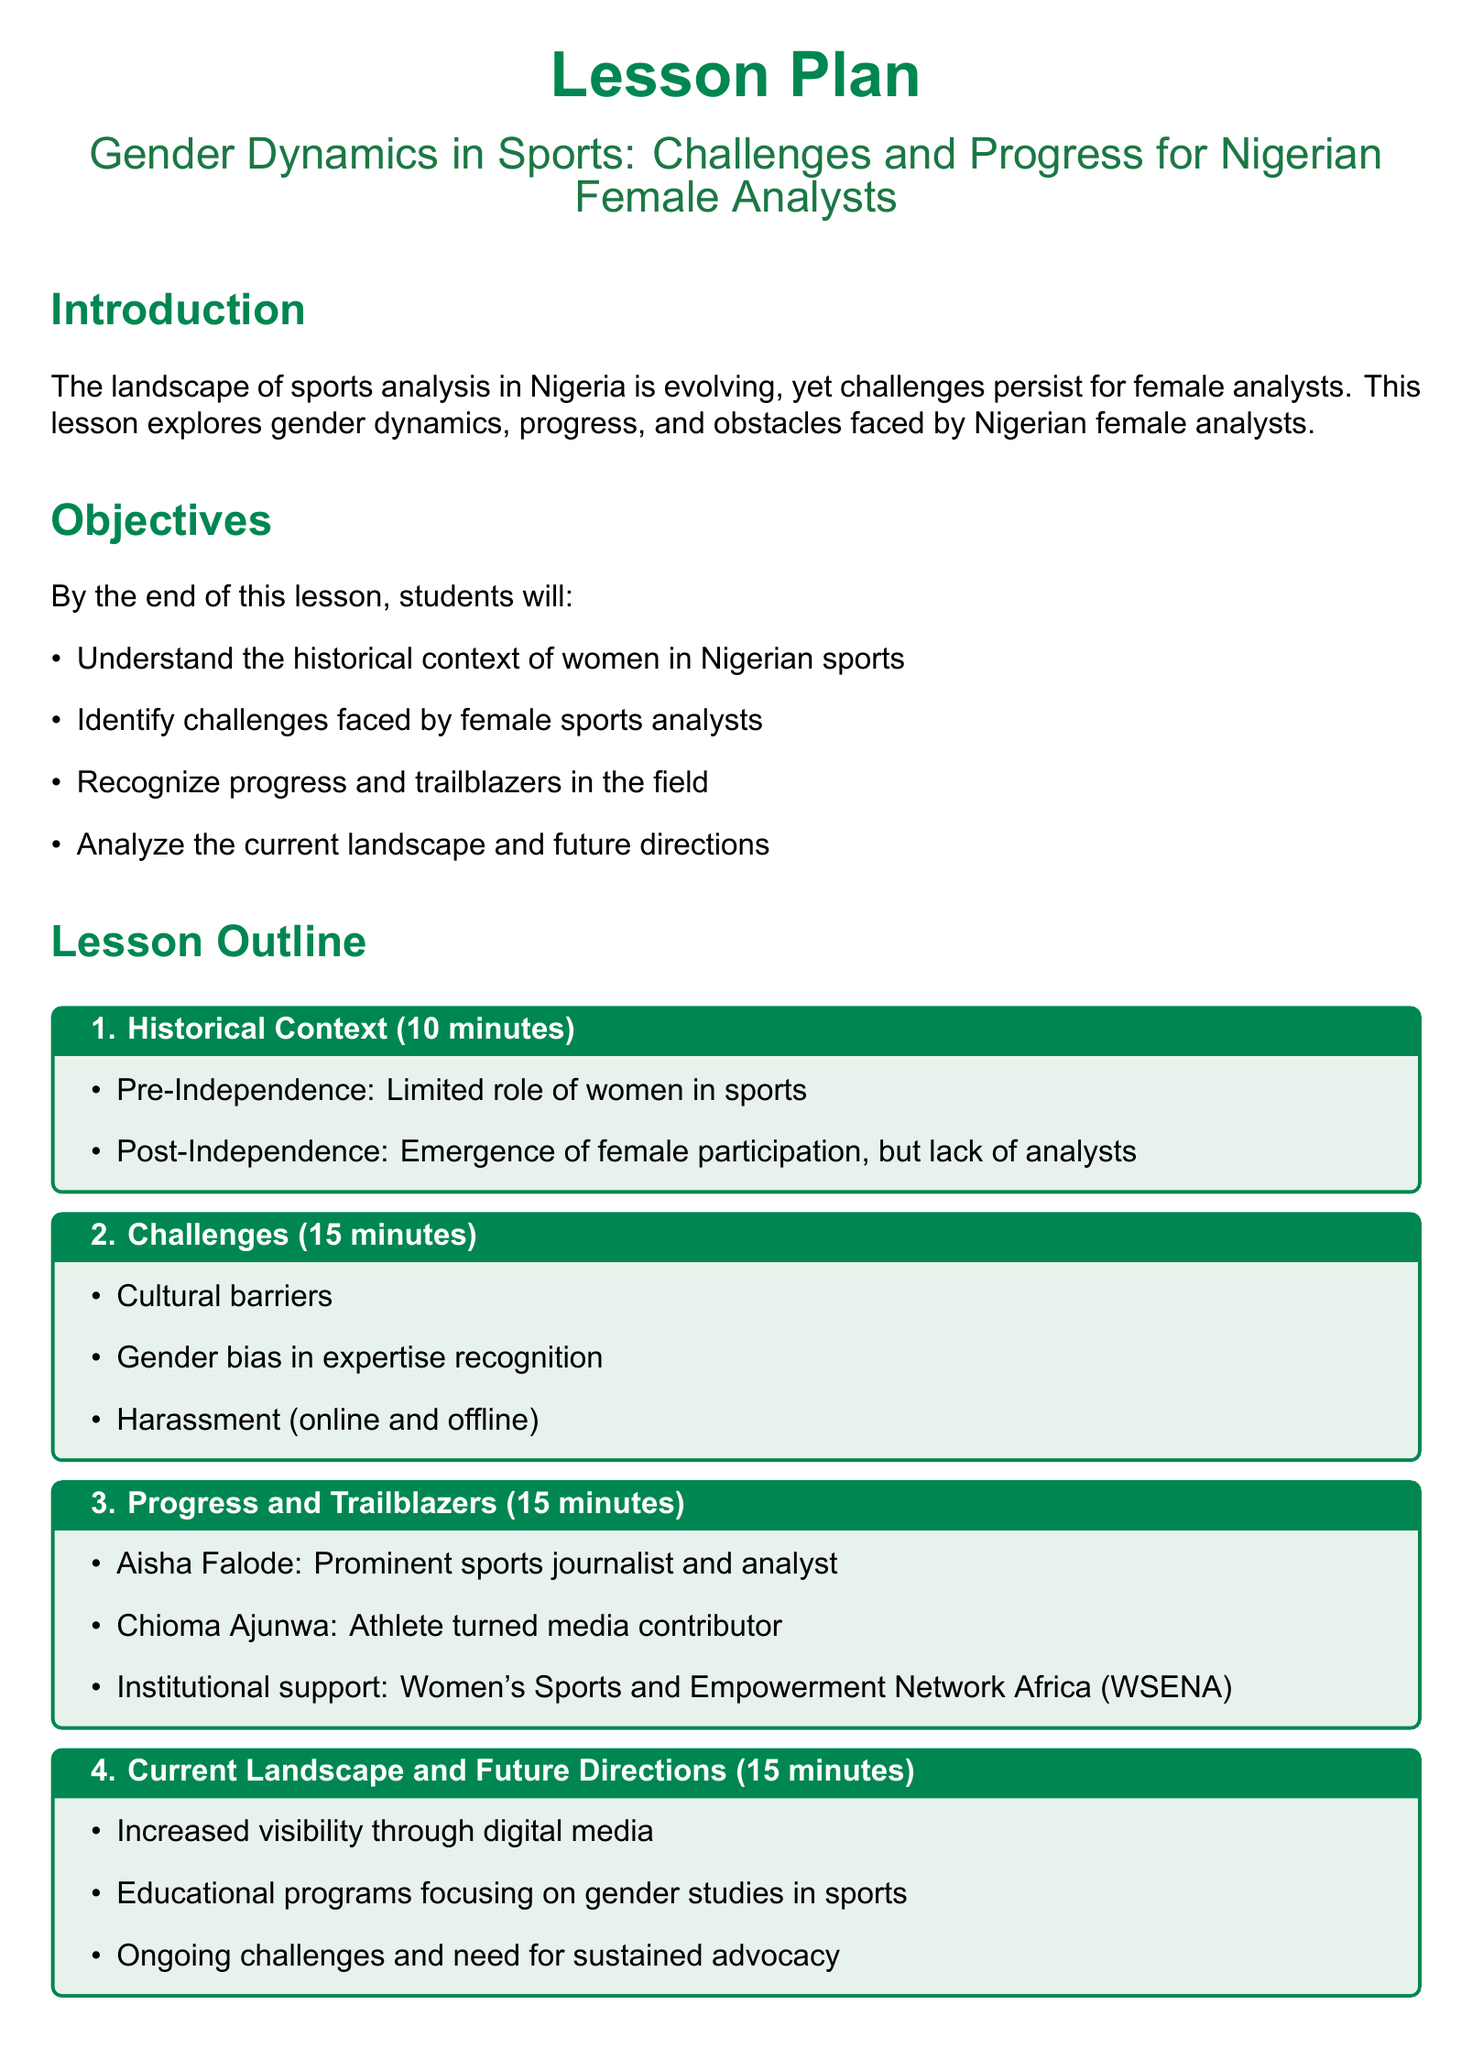What is the title of the lesson? The title of the lesson is explicitly mentioned in the document as "Gender Dynamics in Sports: Challenges and Progress for Nigerian Female Analysts."
Answer: Gender Dynamics in Sports: Challenges and Progress for Nigerian Female Analysts How long is the section on challenges? The duration for the challenges section is specified in the outline, which states it lasts for 15 minutes.
Answer: 15 minutes Who is a prominent sports journalist mentioned in the progress section? The document identifies Aisha Falode as a prominent sports journalist and analyst in the progress section.
Answer: Aisha Falode What are the objectives of the lesson? The objectives of the lesson provide specific outcomes, one of which is to understand the historical context of women in Nigerian sports.
Answer: Understand the historical context of women in Nigerian sports Name one institutional support mentioned in the document. The document mentions the Women's Sports and Empowerment Network Africa (WSENA) as an institutional support for female analysts.
Answer: Women's Sports and Empowerment Network Africa (WSENA) What is one of the activities planned for the lesson? The document includes a group discussion as one of the activities planned for the lesson to analyze a recent sports event commentary.
Answer: Group Discussion What is the total time allocated for the lesson activities? Summing up the time allocated in the activities section gives a total of 20 minutes (10 minutes for group discussion and 10 minutes for role-play).
Answer: 20 minutes What is the conclusion time allocated? The document specifies that the conclusion will take 5 minutes.
Answer: 5 minutes 